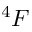Convert formula to latex. <formula><loc_0><loc_0><loc_500><loc_500>^ { 4 } F</formula> 